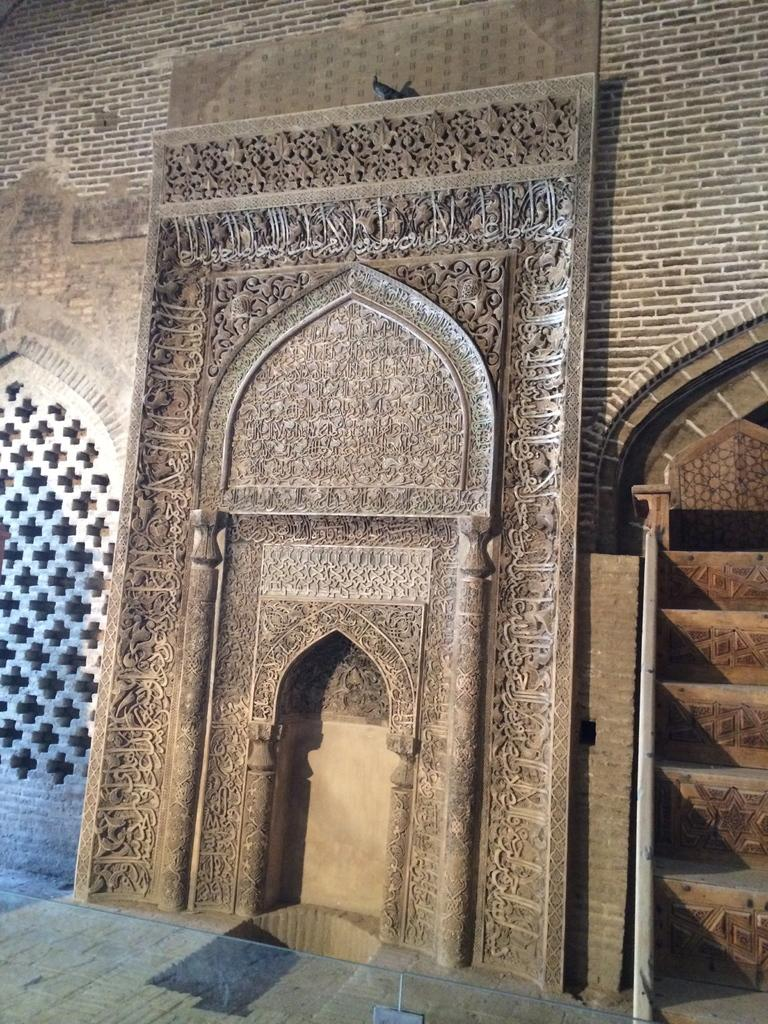What is present on the wall in the image? There is something written on the wall in the image. Can you describe the bird in the image? The image contains a bird, but no specific details about the bird are provided. What is the bird doing in the image? The facts do not specify what the bird is doing in the image. What direction is the hand pointing in the image? There is no hand present in the image. What type of joke is written on the wall in the image? The facts do not indicate that the writing on the wall is a joke. 